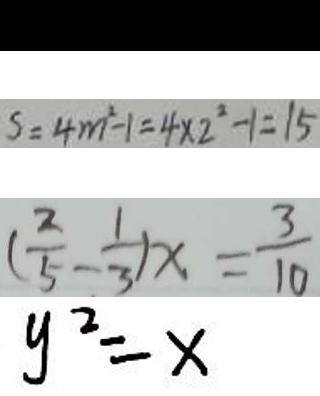Convert formula to latex. <formula><loc_0><loc_0><loc_500><loc_500>a \div b = a ( 1 \div b ) 
 S = 4 m ^ { 2 } - 1 = 4 \times 2 ^ { 2 } - 1 = 1 5 
 ( \frac { 2 } { 5 } - \frac { 1 } { 3 } ) x = \frac { 3 } { 1 0 } 
 y ^ { 2 } = x</formula> 